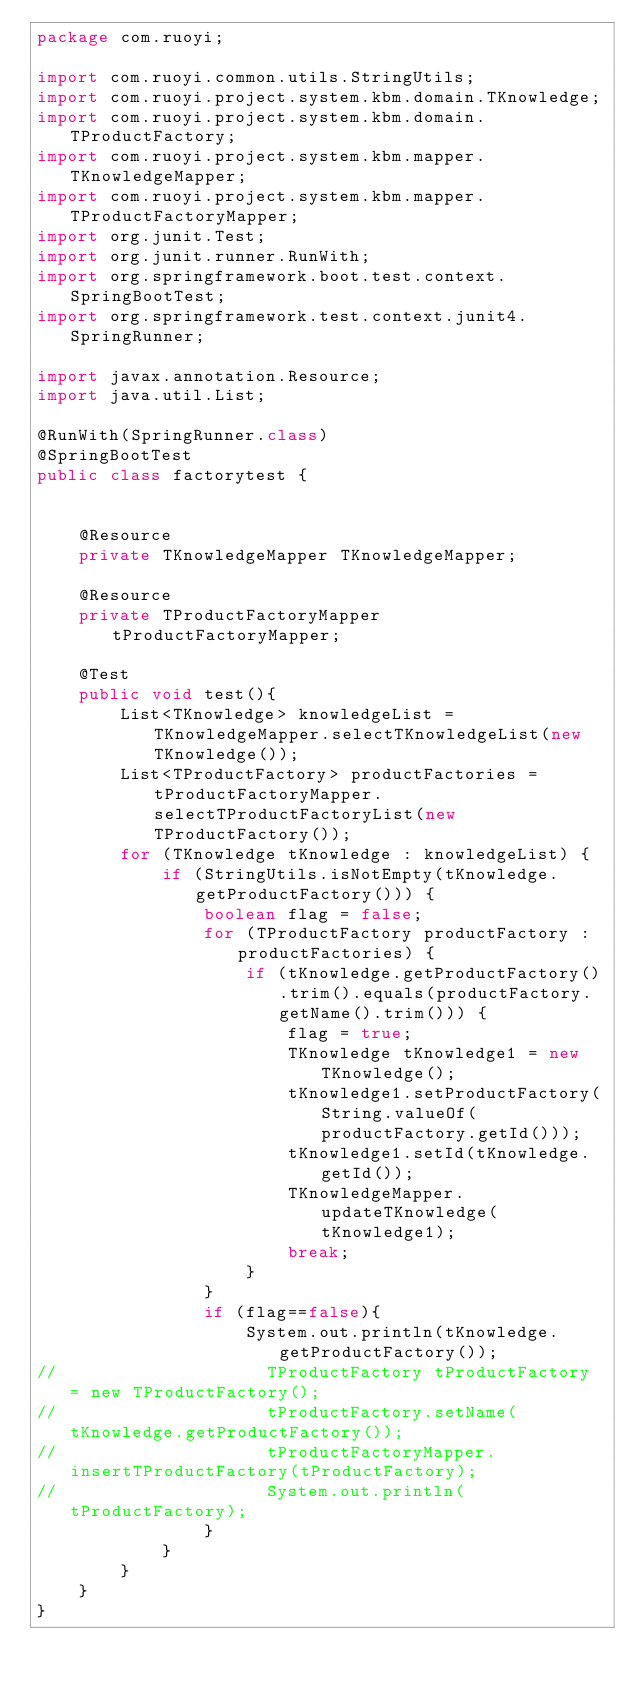Convert code to text. <code><loc_0><loc_0><loc_500><loc_500><_Java_>package com.ruoyi;

import com.ruoyi.common.utils.StringUtils;
import com.ruoyi.project.system.kbm.domain.TKnowledge;
import com.ruoyi.project.system.kbm.domain.TProductFactory;
import com.ruoyi.project.system.kbm.mapper.TKnowledgeMapper;
import com.ruoyi.project.system.kbm.mapper.TProductFactoryMapper;
import org.junit.Test;
import org.junit.runner.RunWith;
import org.springframework.boot.test.context.SpringBootTest;
import org.springframework.test.context.junit4.SpringRunner;

import javax.annotation.Resource;
import java.util.List;

@RunWith(SpringRunner.class)
@SpringBootTest
public class factorytest {


    @Resource
    private TKnowledgeMapper TKnowledgeMapper;

    @Resource
    private TProductFactoryMapper tProductFactoryMapper;

    @Test
    public void test(){
        List<TKnowledge> knowledgeList = TKnowledgeMapper.selectTKnowledgeList(new TKnowledge());
        List<TProductFactory> productFactories = tProductFactoryMapper.selectTProductFactoryList(new TProductFactory());
        for (TKnowledge tKnowledge : knowledgeList) {
            if (StringUtils.isNotEmpty(tKnowledge.getProductFactory())) {
                boolean flag = false;
                for (TProductFactory productFactory : productFactories) {
                    if (tKnowledge.getProductFactory().trim().equals(productFactory.getName().trim())) {
                        flag = true;
                        TKnowledge tKnowledge1 = new TKnowledge();
                        tKnowledge1.setProductFactory(String.valueOf(productFactory.getId()));
                        tKnowledge1.setId(tKnowledge.getId());
                        TKnowledgeMapper.updateTKnowledge(tKnowledge1);
                        break;
                    }
                }
                if (flag==false){
                    System.out.println(tKnowledge.getProductFactory());
//                    TProductFactory tProductFactory = new TProductFactory();
//                    tProductFactory.setName(tKnowledge.getProductFactory());
//                    tProductFactoryMapper.insertTProductFactory(tProductFactory);
//                    System.out.println(tProductFactory);
                }
            }
        }
    }
}
</code> 